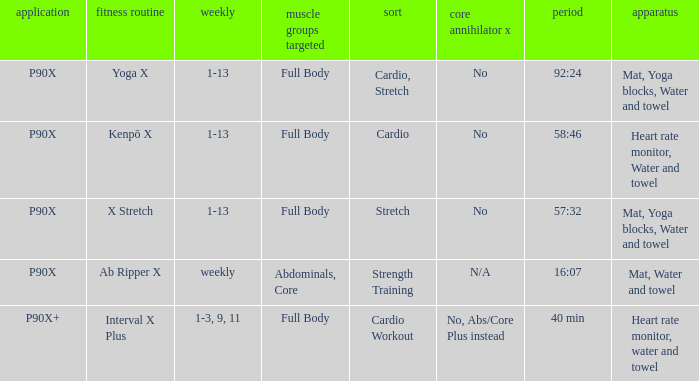How many types are cardio? 1.0. Would you be able to parse every entry in this table? {'header': ['application', 'fitness routine', 'weekly', 'muscle groups targeted', 'sort', 'core annihilator x', 'period', 'apparatus'], 'rows': [['P90X', 'Yoga X', '1-13', 'Full Body', 'Cardio, Stretch', 'No', '92:24', 'Mat, Yoga blocks, Water and towel'], ['P90X', 'Kenpō X', '1-13', 'Full Body', 'Cardio', 'No', '58:46', 'Heart rate monitor, Water and towel'], ['P90X', 'X Stretch', '1-13', 'Full Body', 'Stretch', 'No', '57:32', 'Mat, Yoga blocks, Water and towel'], ['P90X', 'Ab Ripper X', 'weekly', 'Abdominals, Core', 'Strength Training', 'N/A', '16:07', 'Mat, Water and towel'], ['P90X+', 'Interval X Plus', '1-3, 9, 11', 'Full Body', 'Cardio Workout', 'No, Abs/Core Plus instead', '40 min', 'Heart rate monitor, water and towel']]} 